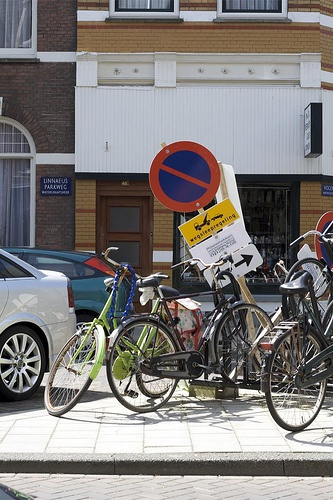Describe the objects in this image and their specific colors. I can see bicycle in gray, black, lightgray, and darkgray tones, car in gray, darkgray, black, and lightgray tones, bicycle in gray, black, white, and darkgray tones, bicycle in gray, lightgray, black, and darkgray tones, and car in gray, blue, navy, and black tones in this image. 